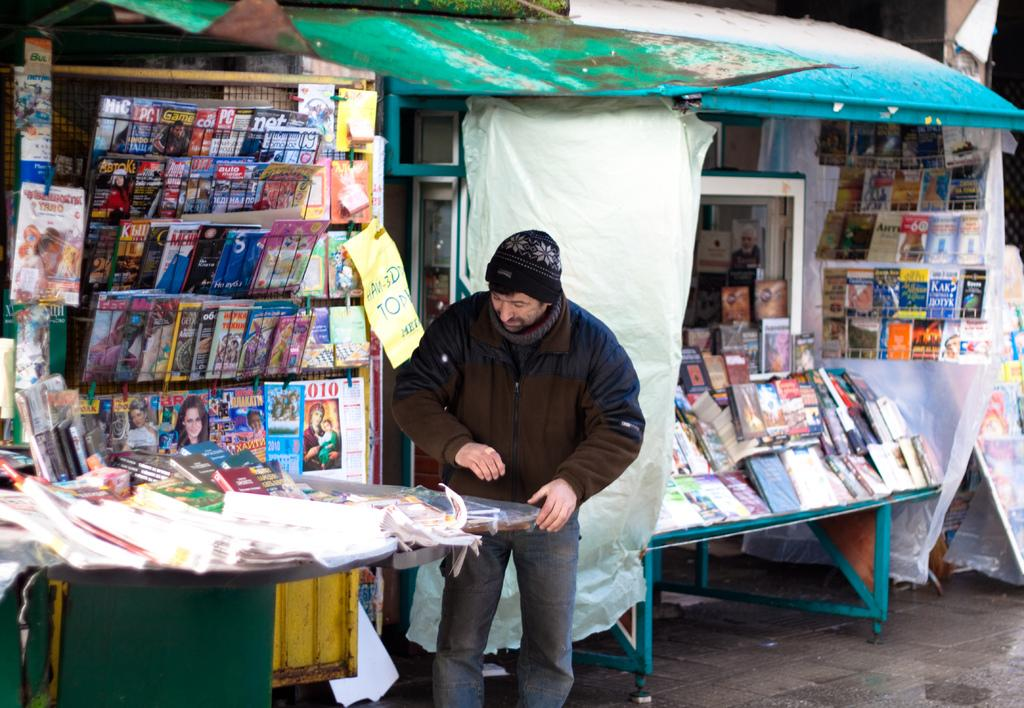What is the main subject of the image? There is a man standing in the image. What objects are on the table in the image? There are books and magazines on the table in the image. Can you see a yak grazing in the background of the image? There is no yak present in the image. What emotion does the man appear to be feeling in the image? The provided facts do not mention the man's emotions or facial expressions, so it cannot be determined from the image. 